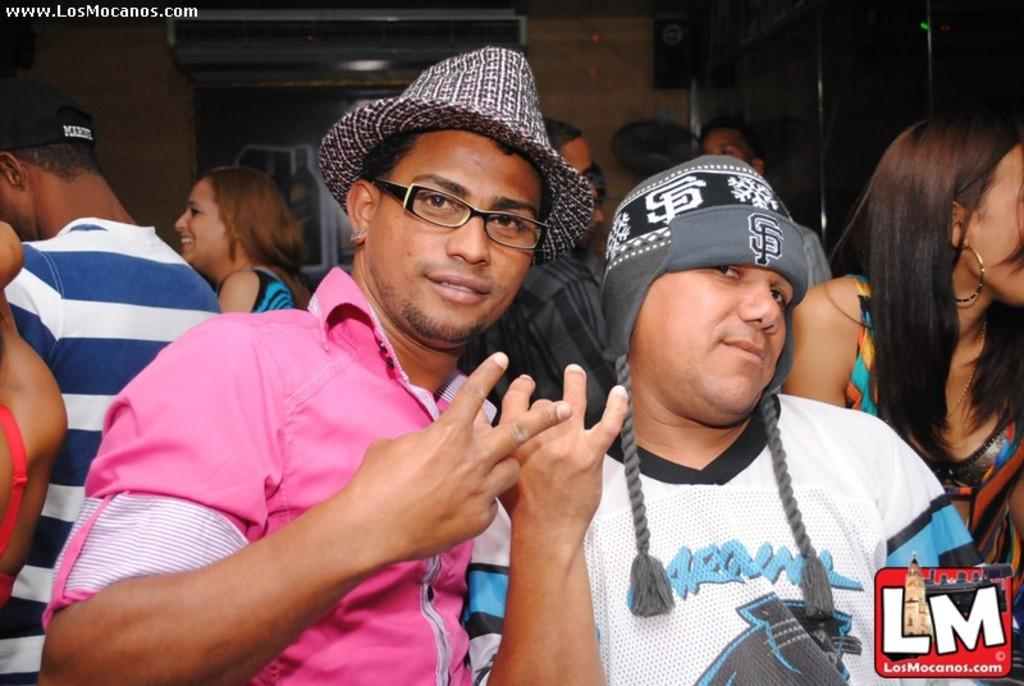How many people are standing in the front of the image? There are two persons standing in the front of the image. Can you describe the appearance of one of the persons in the front? One of the persons is a man wearing a pink shirt and a hat. What can be seen in the background of the image? There are many people and a wall visible in the background of the image. What type of agreement is being discussed by the donkey in the image? There is no donkey present in the image, so no agreement can be discussed by a donkey. 